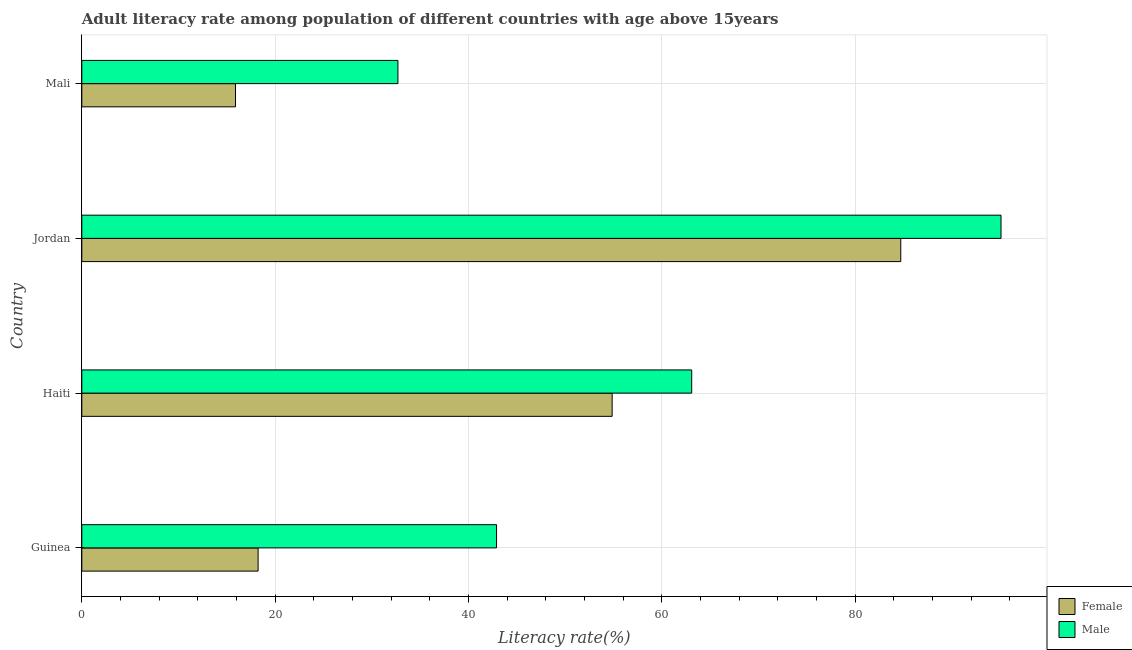Are the number of bars per tick equal to the number of legend labels?
Your answer should be compact. Yes. What is the label of the 2nd group of bars from the top?
Offer a terse response. Jordan. In how many cases, is the number of bars for a given country not equal to the number of legend labels?
Provide a succinct answer. 0. What is the female adult literacy rate in Haiti?
Ensure brevity in your answer.  54.86. Across all countries, what is the maximum male adult literacy rate?
Ensure brevity in your answer.  95.08. Across all countries, what is the minimum female adult literacy rate?
Make the answer very short. 15.9. In which country was the female adult literacy rate maximum?
Keep it short and to the point. Jordan. In which country was the male adult literacy rate minimum?
Your response must be concise. Mali. What is the total female adult literacy rate in the graph?
Your answer should be very brief. 173.71. What is the difference between the female adult literacy rate in Jordan and that in Mali?
Keep it short and to the point. 68.81. What is the difference between the female adult literacy rate in Guinea and the male adult literacy rate in Jordan?
Provide a succinct answer. -76.85. What is the average female adult literacy rate per country?
Provide a succinct answer. 43.43. What is the ratio of the female adult literacy rate in Guinea to that in Mali?
Ensure brevity in your answer.  1.15. Is the difference between the female adult literacy rate in Guinea and Jordan greater than the difference between the male adult literacy rate in Guinea and Jordan?
Provide a short and direct response. No. What is the difference between the highest and the second highest female adult literacy rate?
Ensure brevity in your answer.  29.85. What is the difference between the highest and the lowest female adult literacy rate?
Your answer should be very brief. 68.81. Is the sum of the male adult literacy rate in Guinea and Mali greater than the maximum female adult literacy rate across all countries?
Your answer should be compact. No. What does the 2nd bar from the top in Jordan represents?
Your answer should be compact. Female. How many bars are there?
Your response must be concise. 8. What is the difference between two consecutive major ticks on the X-axis?
Keep it short and to the point. 20. What is the title of the graph?
Your answer should be compact. Adult literacy rate among population of different countries with age above 15years. What is the label or title of the X-axis?
Give a very brief answer. Literacy rate(%). What is the Literacy rate(%) of Female in Guinea?
Provide a succinct answer. 18.24. What is the Literacy rate(%) of Male in Guinea?
Offer a very short reply. 42.9. What is the Literacy rate(%) of Female in Haiti?
Give a very brief answer. 54.86. What is the Literacy rate(%) in Male in Haiti?
Make the answer very short. 63.09. What is the Literacy rate(%) of Female in Jordan?
Ensure brevity in your answer.  84.71. What is the Literacy rate(%) in Male in Jordan?
Make the answer very short. 95.08. What is the Literacy rate(%) in Female in Mali?
Your answer should be compact. 15.9. What is the Literacy rate(%) of Male in Mali?
Ensure brevity in your answer.  32.7. Across all countries, what is the maximum Literacy rate(%) of Female?
Provide a short and direct response. 84.71. Across all countries, what is the maximum Literacy rate(%) in Male?
Your response must be concise. 95.08. Across all countries, what is the minimum Literacy rate(%) in Female?
Offer a very short reply. 15.9. Across all countries, what is the minimum Literacy rate(%) of Male?
Keep it short and to the point. 32.7. What is the total Literacy rate(%) in Female in the graph?
Your answer should be compact. 173.71. What is the total Literacy rate(%) of Male in the graph?
Your answer should be very brief. 233.78. What is the difference between the Literacy rate(%) in Female in Guinea and that in Haiti?
Provide a short and direct response. -36.62. What is the difference between the Literacy rate(%) of Male in Guinea and that in Haiti?
Provide a succinct answer. -20.19. What is the difference between the Literacy rate(%) of Female in Guinea and that in Jordan?
Provide a succinct answer. -66.48. What is the difference between the Literacy rate(%) of Male in Guinea and that in Jordan?
Ensure brevity in your answer.  -52.18. What is the difference between the Literacy rate(%) of Female in Guinea and that in Mali?
Your answer should be very brief. 2.34. What is the difference between the Literacy rate(%) of Male in Guinea and that in Mali?
Make the answer very short. 10.2. What is the difference between the Literacy rate(%) of Female in Haiti and that in Jordan?
Give a very brief answer. -29.85. What is the difference between the Literacy rate(%) in Male in Haiti and that in Jordan?
Give a very brief answer. -31.99. What is the difference between the Literacy rate(%) in Female in Haiti and that in Mali?
Your answer should be compact. 38.96. What is the difference between the Literacy rate(%) in Male in Haiti and that in Mali?
Your response must be concise. 30.39. What is the difference between the Literacy rate(%) in Female in Jordan and that in Mali?
Ensure brevity in your answer.  68.81. What is the difference between the Literacy rate(%) in Male in Jordan and that in Mali?
Make the answer very short. 62.38. What is the difference between the Literacy rate(%) of Female in Guinea and the Literacy rate(%) of Male in Haiti?
Your response must be concise. -44.85. What is the difference between the Literacy rate(%) in Female in Guinea and the Literacy rate(%) in Male in Jordan?
Give a very brief answer. -76.85. What is the difference between the Literacy rate(%) in Female in Guinea and the Literacy rate(%) in Male in Mali?
Offer a terse response. -14.46. What is the difference between the Literacy rate(%) in Female in Haiti and the Literacy rate(%) in Male in Jordan?
Provide a succinct answer. -40.22. What is the difference between the Literacy rate(%) of Female in Haiti and the Literacy rate(%) of Male in Mali?
Your answer should be very brief. 22.16. What is the difference between the Literacy rate(%) of Female in Jordan and the Literacy rate(%) of Male in Mali?
Provide a succinct answer. 52.01. What is the average Literacy rate(%) of Female per country?
Offer a very short reply. 43.43. What is the average Literacy rate(%) in Male per country?
Ensure brevity in your answer.  58.44. What is the difference between the Literacy rate(%) in Female and Literacy rate(%) in Male in Guinea?
Provide a succinct answer. -24.66. What is the difference between the Literacy rate(%) in Female and Literacy rate(%) in Male in Haiti?
Keep it short and to the point. -8.23. What is the difference between the Literacy rate(%) of Female and Literacy rate(%) of Male in Jordan?
Your answer should be compact. -10.37. What is the difference between the Literacy rate(%) in Female and Literacy rate(%) in Male in Mali?
Make the answer very short. -16.8. What is the ratio of the Literacy rate(%) of Female in Guinea to that in Haiti?
Ensure brevity in your answer.  0.33. What is the ratio of the Literacy rate(%) of Male in Guinea to that in Haiti?
Your answer should be compact. 0.68. What is the ratio of the Literacy rate(%) of Female in Guinea to that in Jordan?
Provide a succinct answer. 0.22. What is the ratio of the Literacy rate(%) of Male in Guinea to that in Jordan?
Your response must be concise. 0.45. What is the ratio of the Literacy rate(%) in Female in Guinea to that in Mali?
Your response must be concise. 1.15. What is the ratio of the Literacy rate(%) of Male in Guinea to that in Mali?
Your answer should be very brief. 1.31. What is the ratio of the Literacy rate(%) in Female in Haiti to that in Jordan?
Offer a very short reply. 0.65. What is the ratio of the Literacy rate(%) of Male in Haiti to that in Jordan?
Your response must be concise. 0.66. What is the ratio of the Literacy rate(%) of Female in Haiti to that in Mali?
Provide a short and direct response. 3.45. What is the ratio of the Literacy rate(%) of Male in Haiti to that in Mali?
Give a very brief answer. 1.93. What is the ratio of the Literacy rate(%) in Female in Jordan to that in Mali?
Give a very brief answer. 5.33. What is the ratio of the Literacy rate(%) in Male in Jordan to that in Mali?
Offer a terse response. 2.91. What is the difference between the highest and the second highest Literacy rate(%) of Female?
Offer a terse response. 29.85. What is the difference between the highest and the second highest Literacy rate(%) in Male?
Keep it short and to the point. 31.99. What is the difference between the highest and the lowest Literacy rate(%) of Female?
Ensure brevity in your answer.  68.81. What is the difference between the highest and the lowest Literacy rate(%) of Male?
Offer a terse response. 62.38. 